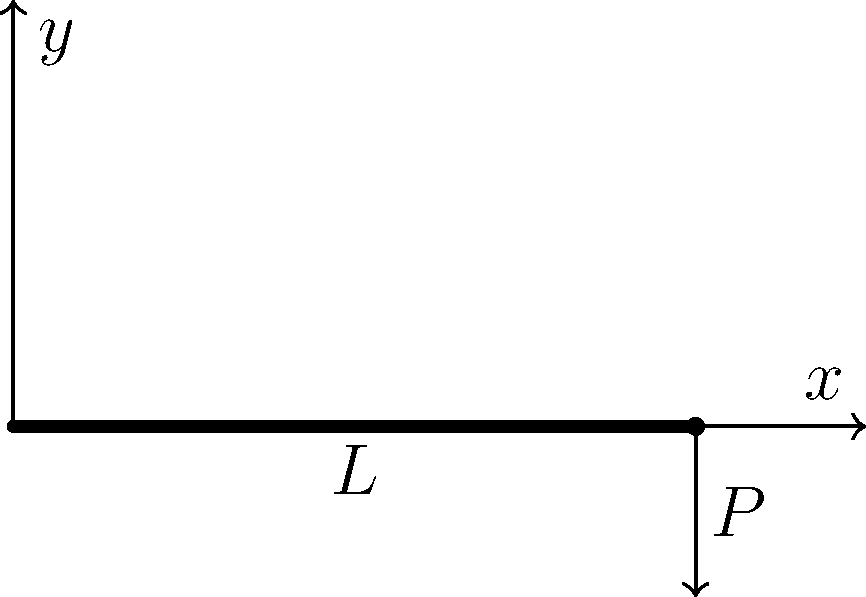As a social media influencer combining psychology and machine learning, you're exploring how AI can predict structural behavior. Consider a cantilever beam of length $L$ with a point load $P$ at its free end. Using the formula $y = \frac{Px^2}{6EI}(3L-x)$, where $E$ is Young's modulus and $I$ is the moment of inertia, what psychological principle might explain why engineers often overestimate the maximum deflection at the beam's end? To answer this question, let's break it down step-by-step:

1) The formula for deflection of a cantilever beam with a point load at its end is:

   $y = \frac{Px^2}{6EI}(3L-x)$

2) The maximum deflection occurs at the free end where $x = L$. Substituting this:

   $y_{max} = \frac{PL^2}{6EI}(3L-L) = \frac{PL^3}{3EI}$

3) This is the correct maximum deflection. However, engineers might overestimate this value due to a psychological principle known as the "worst-case scenario bias" or "negativity bias".

4) Negativity bias is the tendency for humans to give more weight to negative experiences or possibilities than positive ones. In structural engineering, this translates to a tendency to overestimate potential failures or extreme conditions.

5) In machine learning terms, this bias could be seen as a form of overfitting to worst-case scenarios in the training data, leading to overly conservative predictions.

6) The combination of psychology and machine learning could help in developing AI systems that balance this human tendency, potentially leading to more accurate and efficient structural designs.

7) By understanding this psychological principle, we can develop machine learning models that account for this bias, potentially leading to more accurate predictions of structural behavior while maintaining necessary safety margins.
Answer: Negativity bias or worst-case scenario bias 